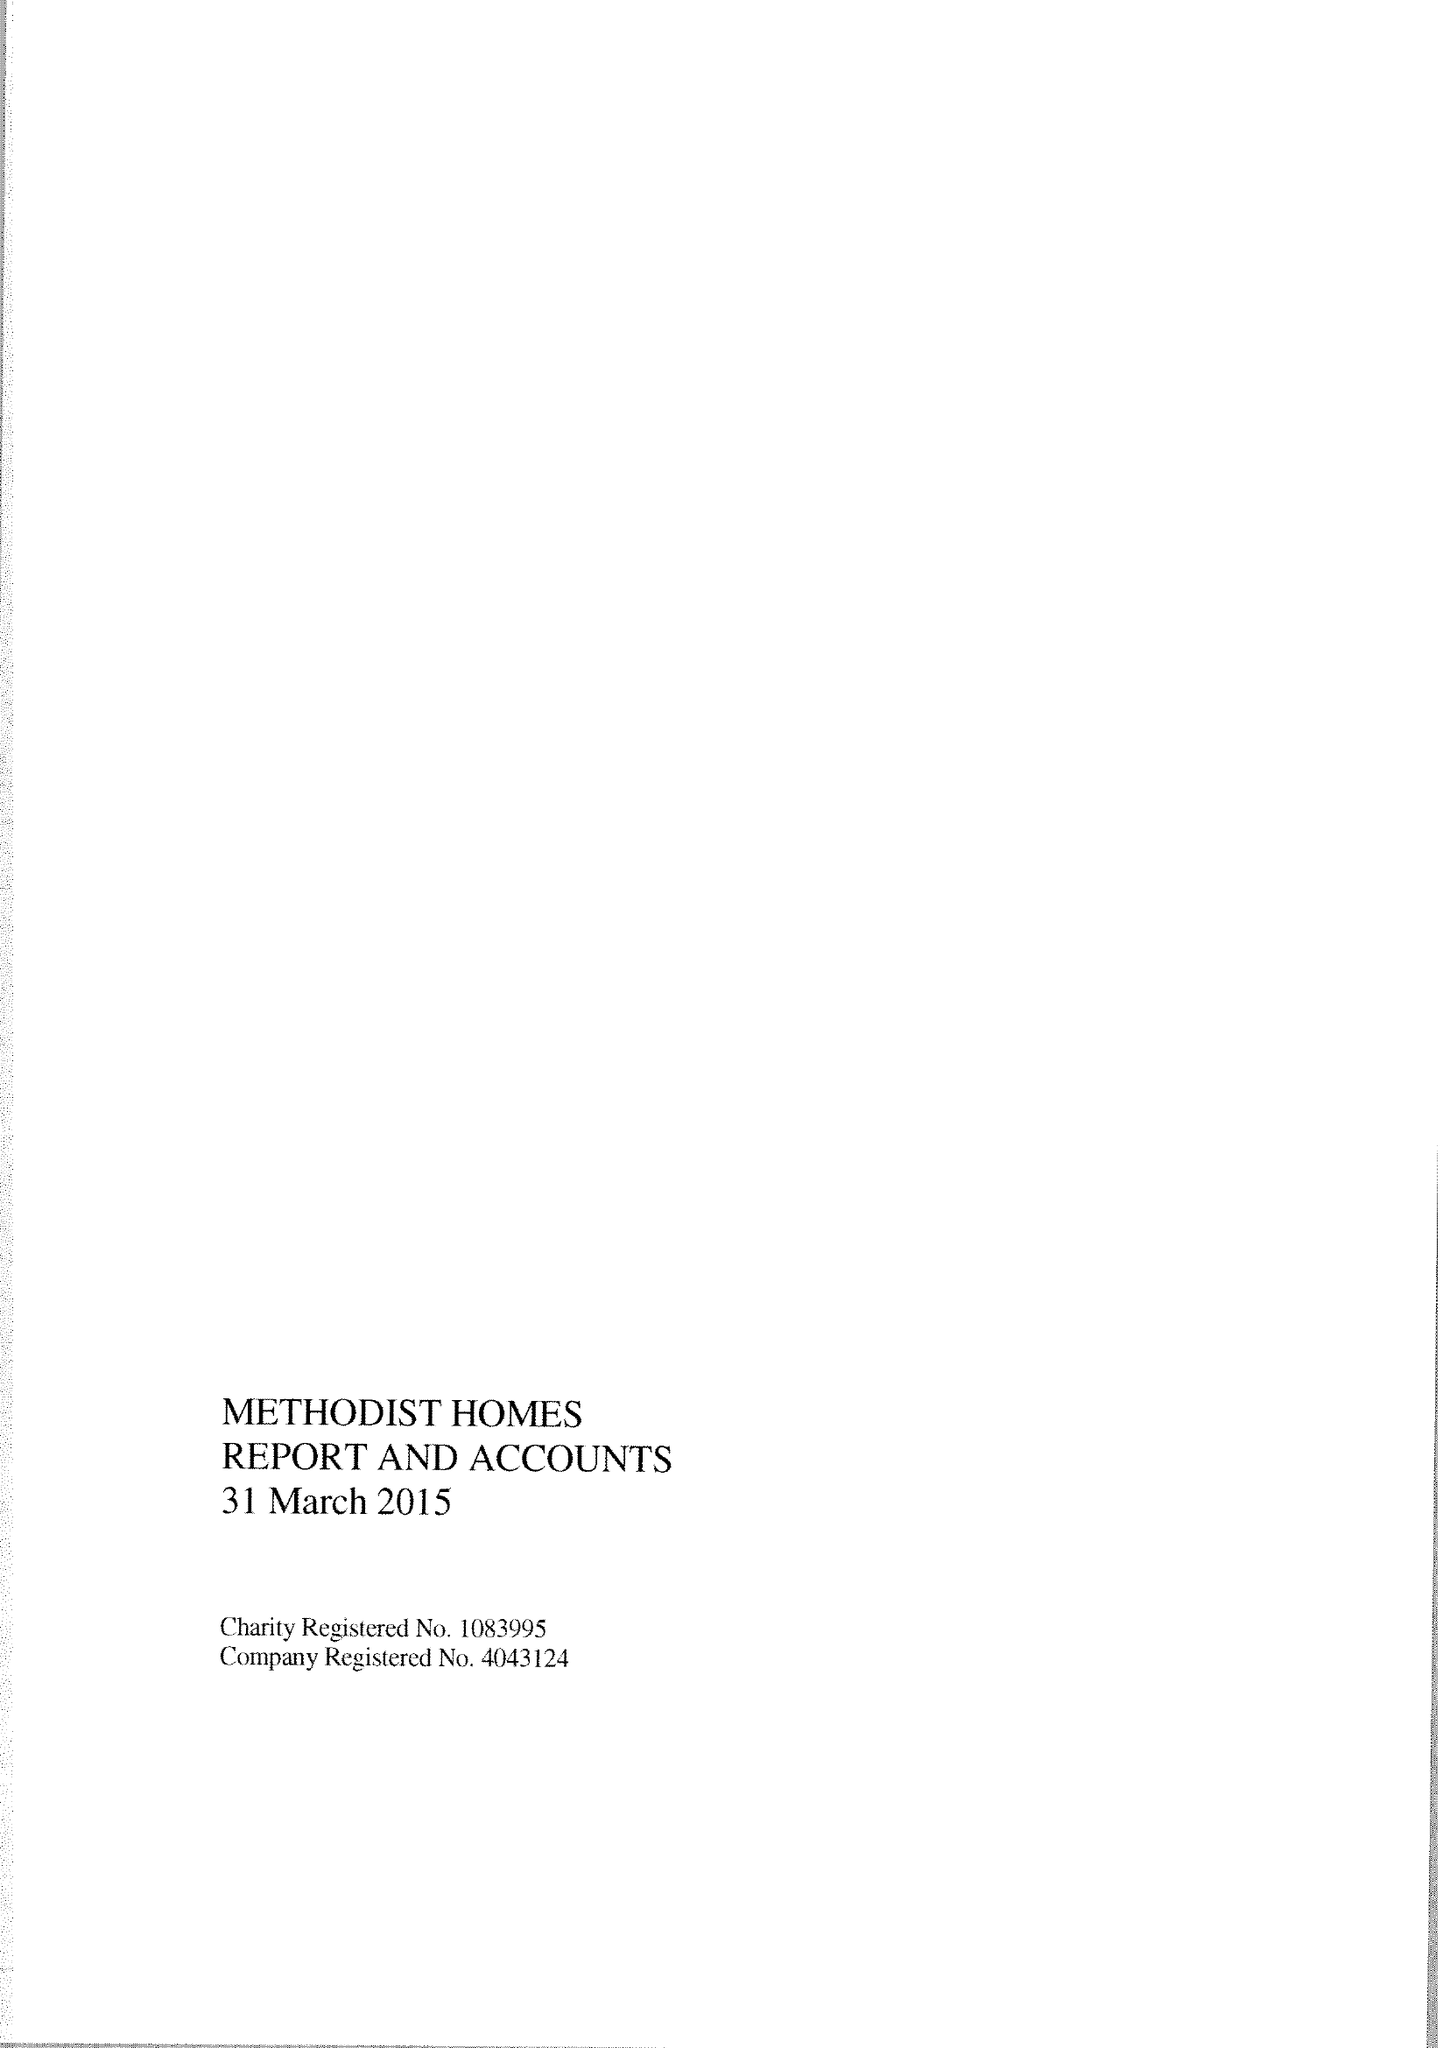What is the value for the report_date?
Answer the question using a single word or phrase. 2015-03-31 